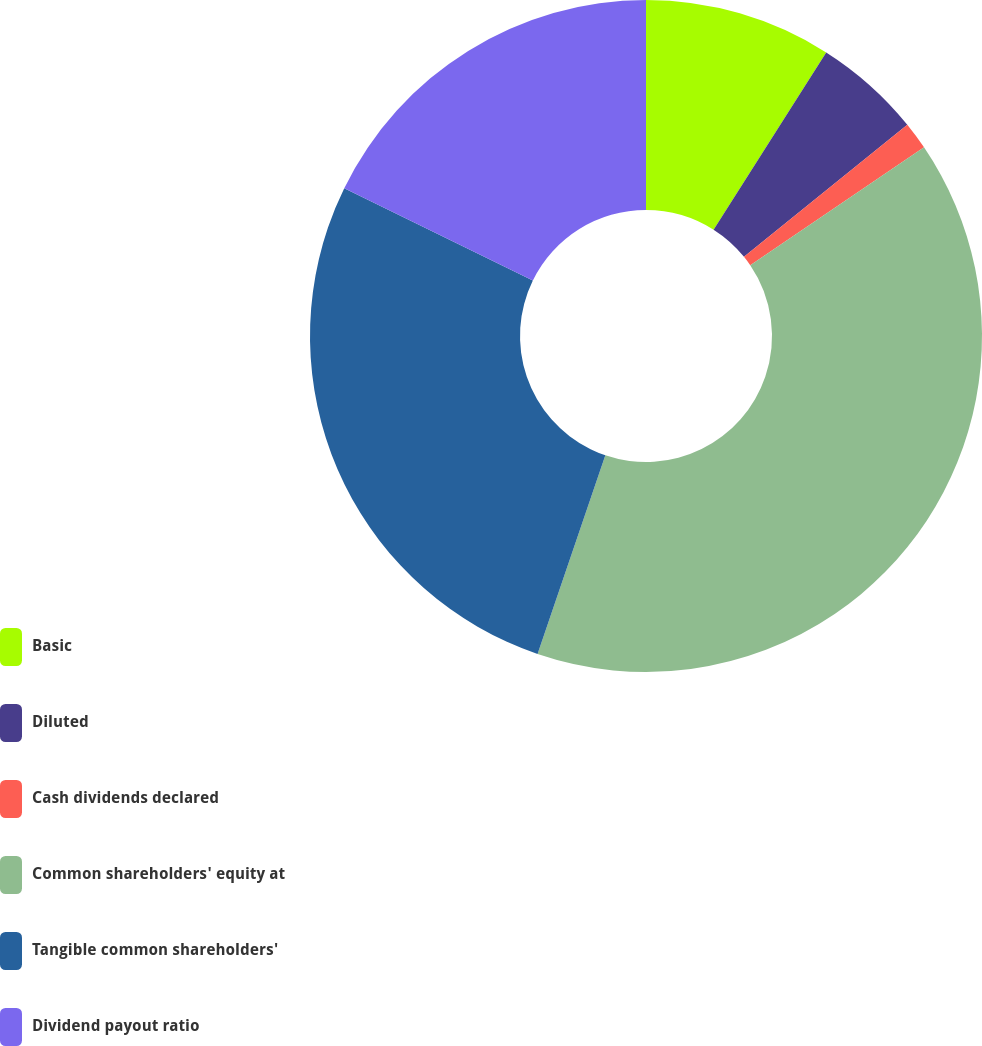Convert chart. <chart><loc_0><loc_0><loc_500><loc_500><pie_chart><fcel>Basic<fcel>Diluted<fcel>Cash dividends declared<fcel>Common shareholders' equity at<fcel>Tangible common shareholders'<fcel>Dividend payout ratio<nl><fcel>9.01%<fcel>5.17%<fcel>1.33%<fcel>39.72%<fcel>27.02%<fcel>17.75%<nl></chart> 